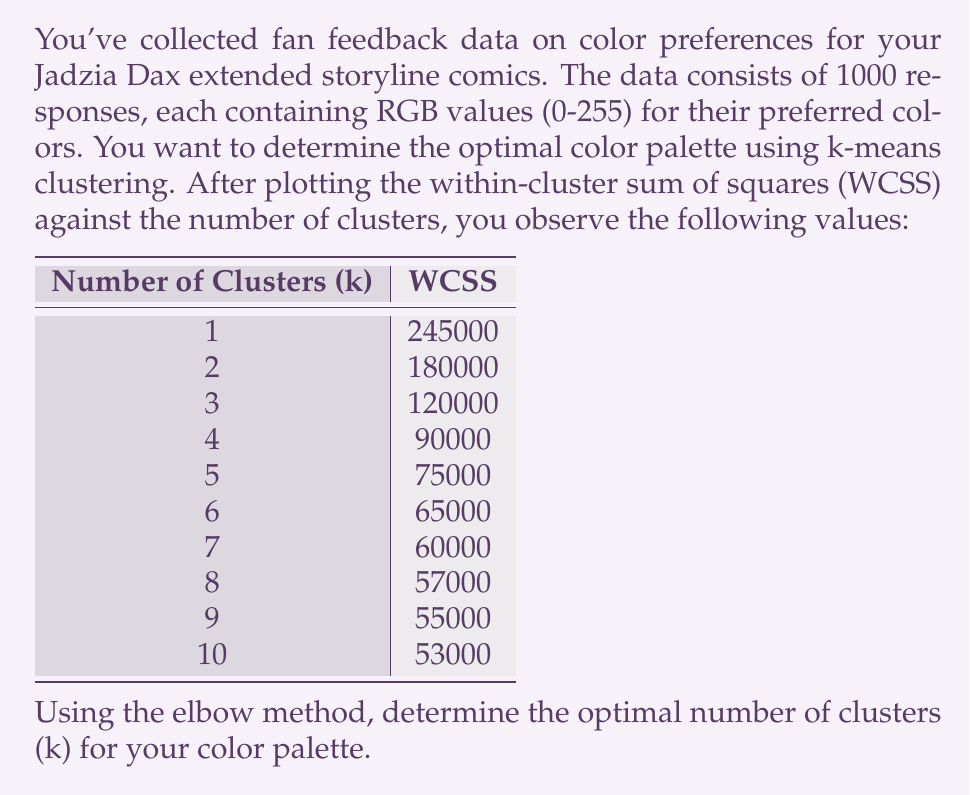Give your solution to this math problem. To determine the optimal number of clusters using the elbow method, we need to analyze the rate of decrease in the Within-Cluster Sum of Squares (WCSS) as the number of clusters increases. The optimal number of clusters is typically found at the "elbow" point, where the rate of decrease in WCSS begins to level off.

Let's calculate the difference in WCSS between consecutive cluster numbers:

$$\begin{array}{c|c|c}
\text{k} & \text{WCSS} & \text{Difference} \\
\hline
1 & 245000 & - \\
2 & 180000 & 65000 \\
3 & 120000 & 60000 \\
4 & 90000 & 30000 \\
5 & 75000 & 15000 \\
6 & 65000 & 10000 \\
7 & 60000 & 5000 \\
8 & 57000 & 3000 \\
9 & 55000 & 2000 \\
10 & 53000 & 2000
\end{array}$$

We can observe that the rate of decrease in WCSS is significant for the first few clusters, but it starts to level off after a certain point. The elbow point is where this leveling off becomes apparent.

In this case, we can see that the difference in WCSS decreases rapidly up to k=4, and then the rate of decrease becomes much slower. The difference between k=3 and k=4 (30000) is still substantial, while the difference between k=4 and k=5 (15000) is significantly smaller.

Therefore, the elbow point appears to be at k=4, suggesting that 4 clusters would be the optimal choice for the color palette.

This choice balances the trade-off between minimizing within-cluster variation and avoiding overfitting with too many clusters. It will provide a diverse yet manageable color palette for the Jadzia Dax extended storyline comics.
Answer: The optimal number of clusters (k) for the color palette is 4. 